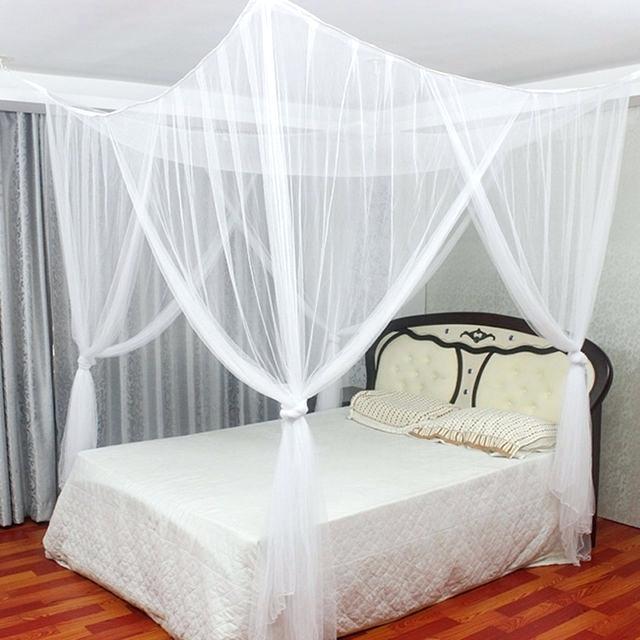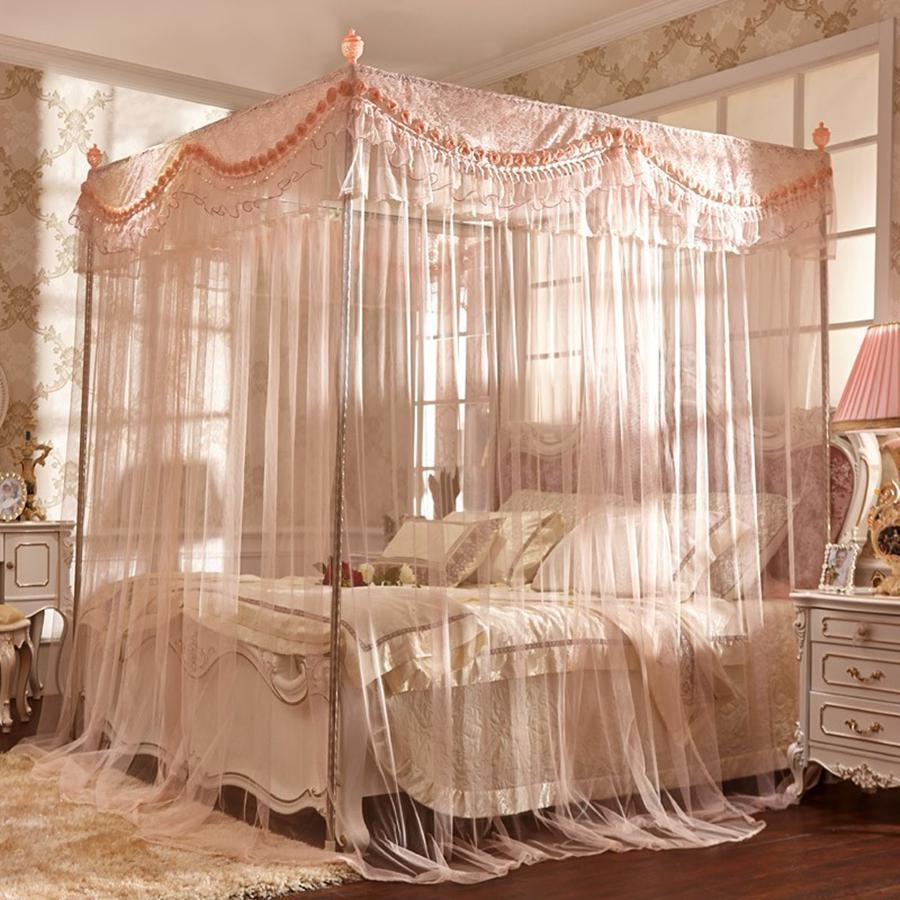The first image is the image on the left, the second image is the image on the right. Considering the images on both sides, is "One image shows a sheer pinkish canopy with a ruffled border around the top, on a four-post bed." valid? Answer yes or no. Yes. The first image is the image on the left, the second image is the image on the right. Examine the images to the left and right. Is the description "The left and right image contains the same number of square open lace canopies." accurate? Answer yes or no. No. 